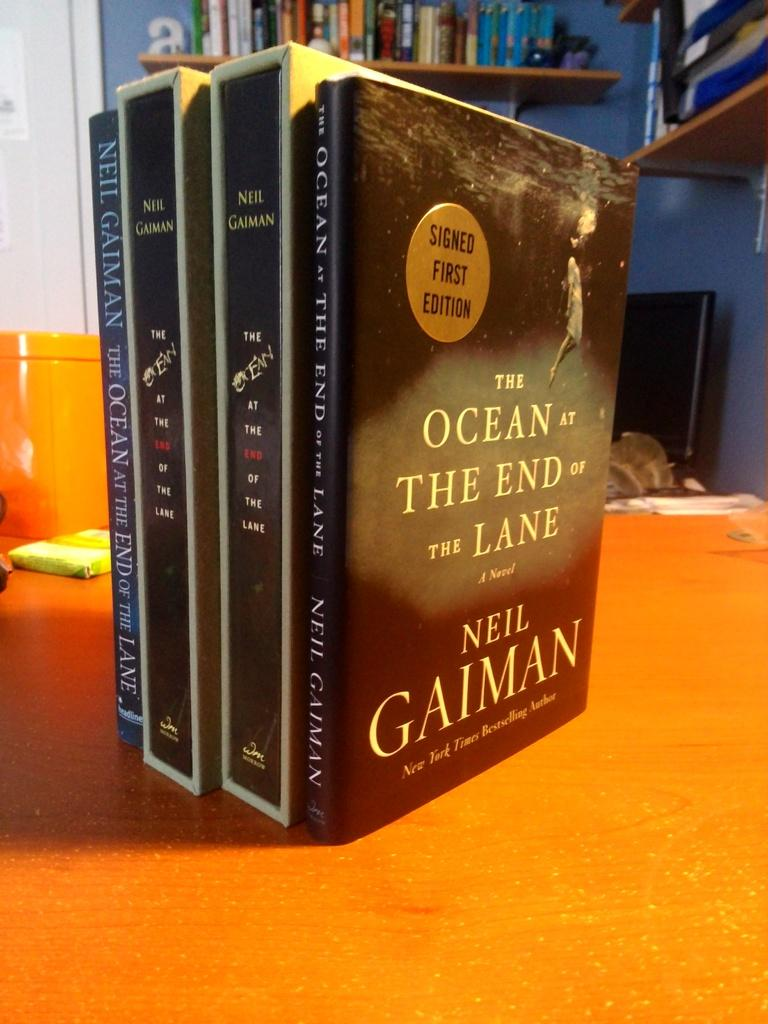<image>
Relay a brief, clear account of the picture shown. A book by Neil Gaiman has a gold circle on it that designates it as a signed first addition. 